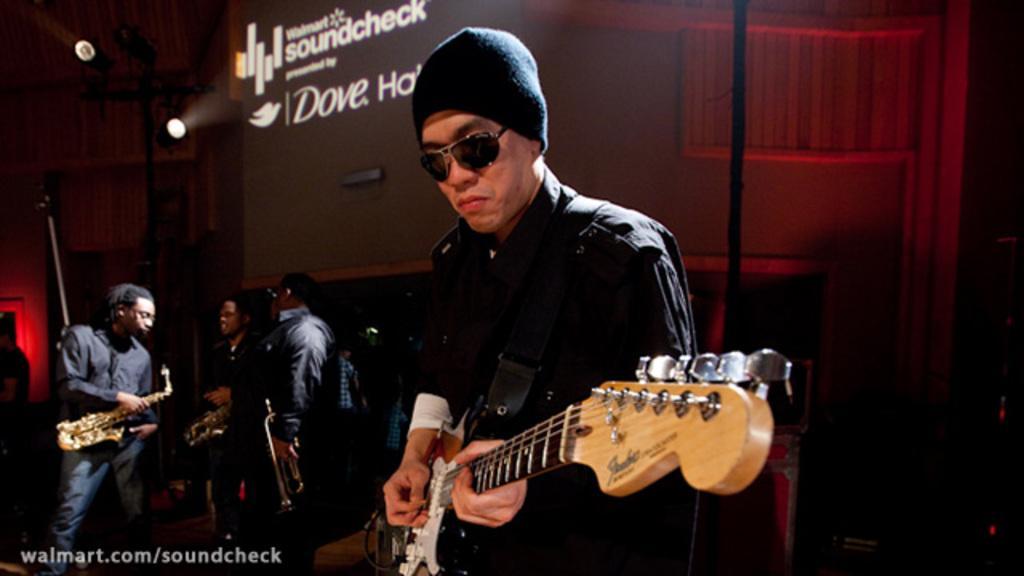Describe this image in one or two sentences. To the right side there is a man with black dress, he is standing and playing a guitar. There is a black cap on his head and he kept googles. And to the left side there is a man with black shirt holding a saxophone in hand. In the middle there are two persons standing, talking and holding musical instruments. In the background top there is a poster. And to the top left there are two lights. 